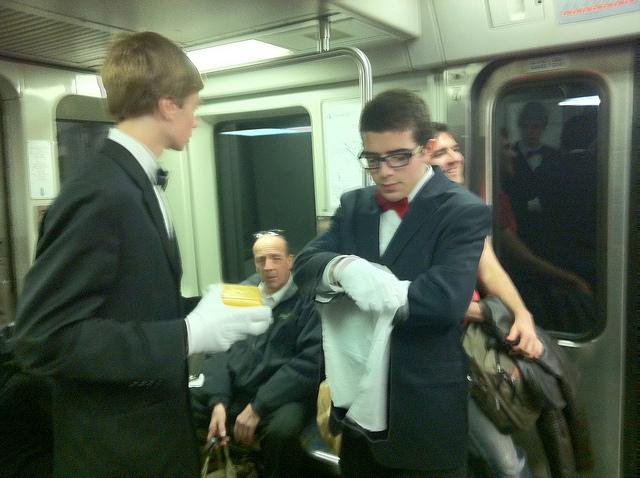Who has gloves on?
Concise answer only. 2 men. Why are the guys in suits?
Short answer required. Work. What type of transportation exists in this scene?
Keep it brief. Subway. Is the train moving?
Quick response, please. Yes. 